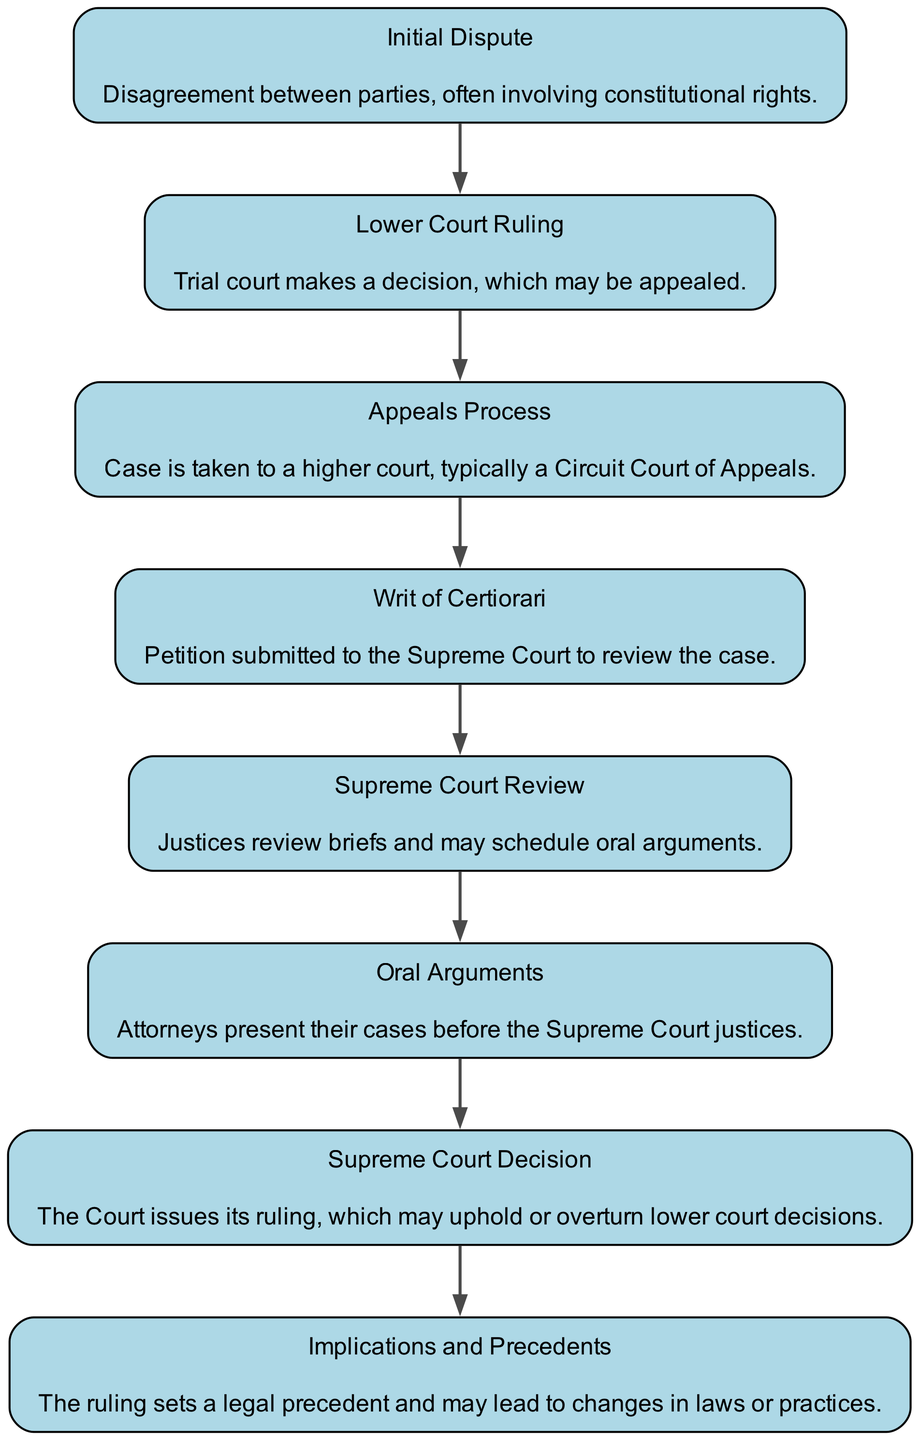What's the first step in the flow chart? The first node in the flow chart is "Initial Dispute" which outlines the starting point of the legal process.
Answer: Initial Dispute How many total steps are there in the diagram? By counting each unique step represented in the flow chart, there are eight distinct steps outlined.
Answer: 8 What follows the "Lower Court Ruling"? The diagram indicates that after "Lower Court Ruling", the next step is "Appeals Process".
Answer: Appeals Process What is the final step in the process? The final node in the flow chart is "Implications and Precedents," which represents the outcomes and broader impacts of the Supreme Court's decisions.
Answer: Implications and Precedents Which step indicates the Supreme Court's review of the case? The node labeled "Supreme Court Review" signifies the stage where justices examine the submitted briefs and schedule arguments.
Answer: Supreme Court Review What precedes "Oral Arguments"? The flow chart shows that "Supreme Court Review" occurs before "Oral Arguments". This indicates the justices prepare for the hearings.
Answer: Supreme Court Review Which step involves presenting cases? The step labeled "Oral Arguments" involves attorneys presenting their positions before the Supreme Court justices.
Answer: Oral Arguments How does the "Writ of Certiorari" function in the process? The "Writ of Certiorari" is a crucial step where a petition is submitted to ask the Supreme Court to take a second look at a case.
Answer: Petition What sets a legal precedent in the flow? The "Supreme Court Decision" step is critical as it results in the court's ruling, which establishes legal precedent for future cases.
Answer: Supreme Court Decision 